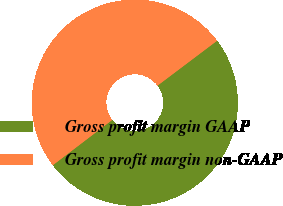Convert chart to OTSL. <chart><loc_0><loc_0><loc_500><loc_500><pie_chart><fcel>Gross profit margin GAAP<fcel>Gross profit margin non-GAAP<nl><fcel>49.91%<fcel>50.09%<nl></chart> 